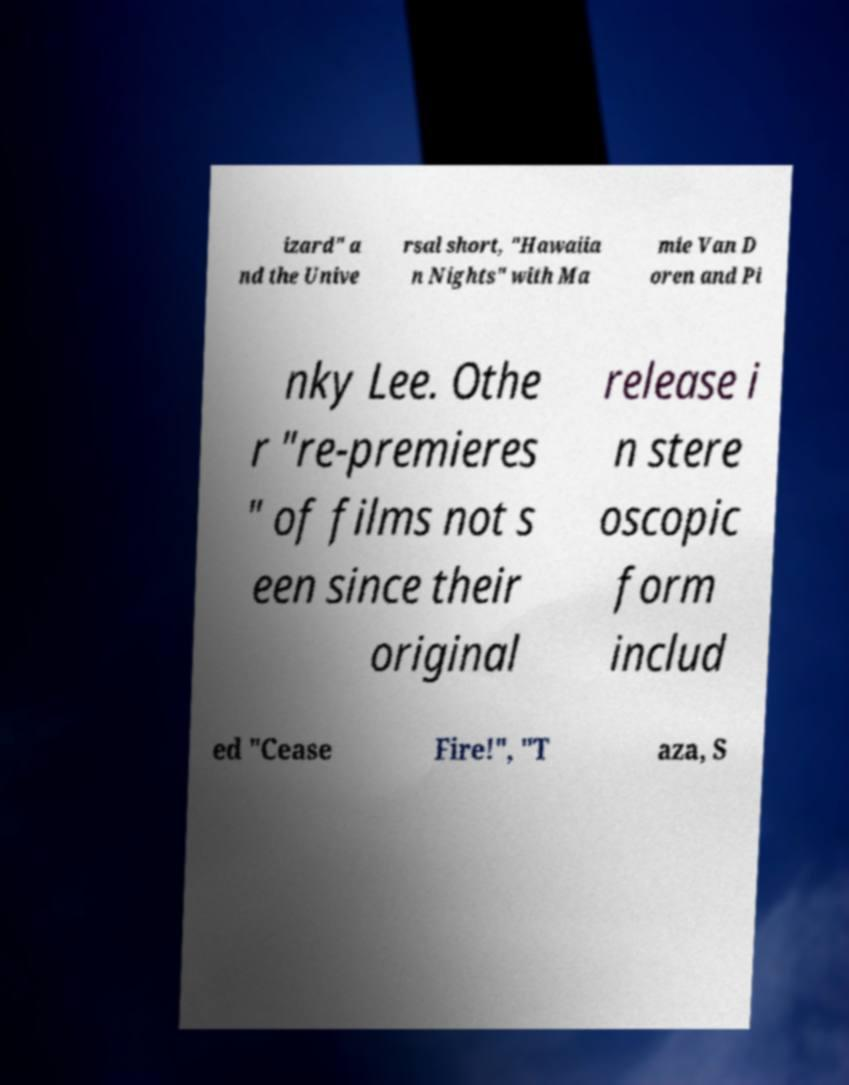Please read and relay the text visible in this image. What does it say? izard" a nd the Unive rsal short, "Hawaiia n Nights" with Ma mie Van D oren and Pi nky Lee. Othe r "re-premieres " of films not s een since their original release i n stere oscopic form includ ed "Cease Fire!", "T aza, S 